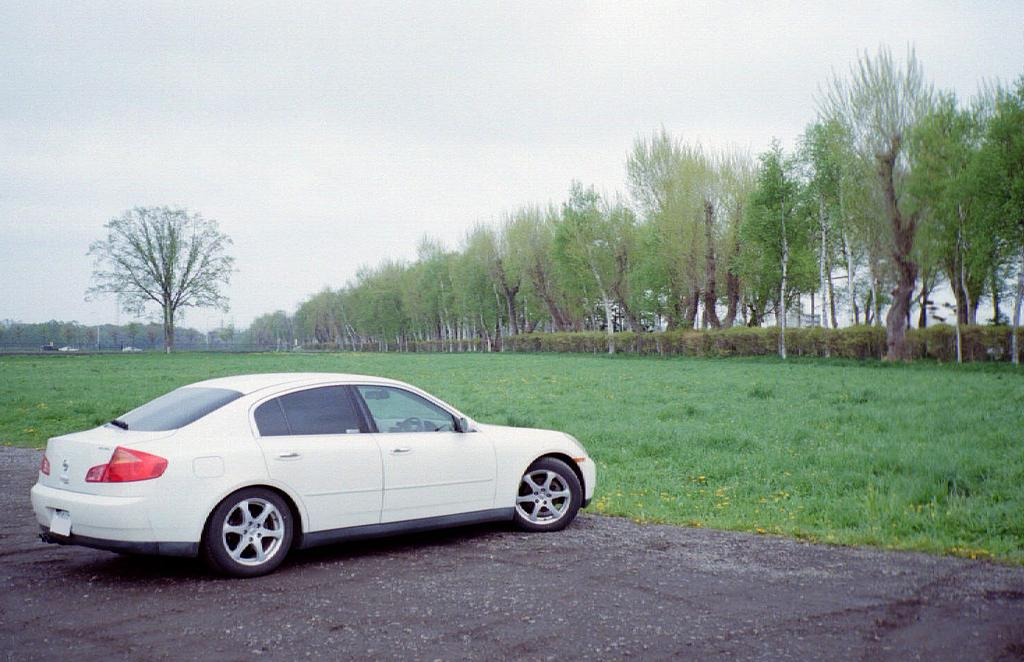What type of vehicle is in the image? There is a white car in the image. Where is the car located? The car is standing on the road. What is the ground surface like in the image? The ground is covered with grass. What can be seen in the background of the image? There are many trees in the image. Where is the faucet located in the image? There is no faucet present in the image. What type of train can be seen passing by in the image? There is no train present in the image. 